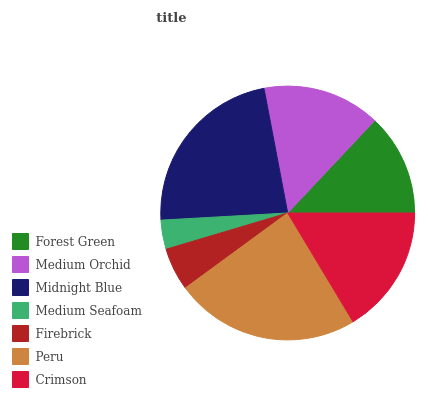Is Medium Seafoam the minimum?
Answer yes or no. Yes. Is Peru the maximum?
Answer yes or no. Yes. Is Medium Orchid the minimum?
Answer yes or no. No. Is Medium Orchid the maximum?
Answer yes or no. No. Is Medium Orchid greater than Forest Green?
Answer yes or no. Yes. Is Forest Green less than Medium Orchid?
Answer yes or no. Yes. Is Forest Green greater than Medium Orchid?
Answer yes or no. No. Is Medium Orchid less than Forest Green?
Answer yes or no. No. Is Medium Orchid the high median?
Answer yes or no. Yes. Is Medium Orchid the low median?
Answer yes or no. Yes. Is Peru the high median?
Answer yes or no. No. Is Forest Green the low median?
Answer yes or no. No. 